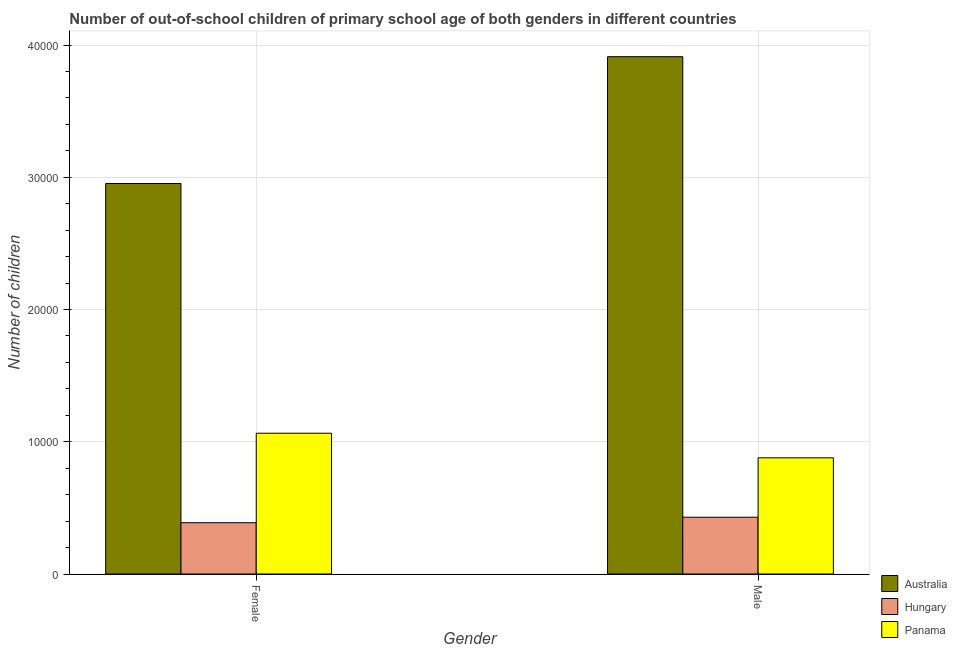How many different coloured bars are there?
Ensure brevity in your answer.  3. Are the number of bars on each tick of the X-axis equal?
Ensure brevity in your answer.  Yes. How many bars are there on the 1st tick from the right?
Make the answer very short. 3. What is the number of female out-of-school students in Australia?
Ensure brevity in your answer.  2.95e+04. Across all countries, what is the maximum number of male out-of-school students?
Offer a very short reply. 3.91e+04. Across all countries, what is the minimum number of male out-of-school students?
Your answer should be compact. 4293. In which country was the number of female out-of-school students maximum?
Ensure brevity in your answer.  Australia. In which country was the number of female out-of-school students minimum?
Provide a short and direct response. Hungary. What is the total number of male out-of-school students in the graph?
Your answer should be very brief. 5.22e+04. What is the difference between the number of male out-of-school students in Panama and that in Australia?
Your answer should be compact. -3.03e+04. What is the difference between the number of female out-of-school students in Hungary and the number of male out-of-school students in Australia?
Your response must be concise. -3.52e+04. What is the average number of male out-of-school students per country?
Make the answer very short. 1.74e+04. What is the difference between the number of female out-of-school students and number of male out-of-school students in Australia?
Provide a succinct answer. -9589. In how many countries, is the number of female out-of-school students greater than 10000 ?
Make the answer very short. 2. What is the ratio of the number of female out-of-school students in Australia to that in Hungary?
Keep it short and to the point. 7.61. In how many countries, is the number of female out-of-school students greater than the average number of female out-of-school students taken over all countries?
Your response must be concise. 1. What does the 3rd bar from the right in Male represents?
Your response must be concise. Australia. Are all the bars in the graph horizontal?
Your answer should be very brief. No. What is the difference between two consecutive major ticks on the Y-axis?
Your answer should be compact. 10000. Are the values on the major ticks of Y-axis written in scientific E-notation?
Your answer should be compact. No. How many legend labels are there?
Ensure brevity in your answer.  3. How are the legend labels stacked?
Make the answer very short. Vertical. What is the title of the graph?
Offer a terse response. Number of out-of-school children of primary school age of both genders in different countries. Does "Rwanda" appear as one of the legend labels in the graph?
Provide a succinct answer. No. What is the label or title of the Y-axis?
Your answer should be very brief. Number of children. What is the Number of children of Australia in Female?
Ensure brevity in your answer.  2.95e+04. What is the Number of children of Hungary in Female?
Offer a terse response. 3879. What is the Number of children of Panama in Female?
Make the answer very short. 1.06e+04. What is the Number of children of Australia in Male?
Ensure brevity in your answer.  3.91e+04. What is the Number of children in Hungary in Male?
Provide a short and direct response. 4293. What is the Number of children in Panama in Male?
Your answer should be very brief. 8786. Across all Gender, what is the maximum Number of children of Australia?
Keep it short and to the point. 3.91e+04. Across all Gender, what is the maximum Number of children of Hungary?
Provide a succinct answer. 4293. Across all Gender, what is the maximum Number of children of Panama?
Offer a very short reply. 1.06e+04. Across all Gender, what is the minimum Number of children in Australia?
Make the answer very short. 2.95e+04. Across all Gender, what is the minimum Number of children in Hungary?
Provide a succinct answer. 3879. Across all Gender, what is the minimum Number of children in Panama?
Your answer should be very brief. 8786. What is the total Number of children in Australia in the graph?
Offer a very short reply. 6.86e+04. What is the total Number of children of Hungary in the graph?
Keep it short and to the point. 8172. What is the total Number of children in Panama in the graph?
Your response must be concise. 1.94e+04. What is the difference between the Number of children in Australia in Female and that in Male?
Provide a short and direct response. -9589. What is the difference between the Number of children of Hungary in Female and that in Male?
Provide a succinct answer. -414. What is the difference between the Number of children in Panama in Female and that in Male?
Provide a short and direct response. 1859. What is the difference between the Number of children of Australia in Female and the Number of children of Hungary in Male?
Your response must be concise. 2.52e+04. What is the difference between the Number of children in Australia in Female and the Number of children in Panama in Male?
Offer a terse response. 2.07e+04. What is the difference between the Number of children in Hungary in Female and the Number of children in Panama in Male?
Keep it short and to the point. -4907. What is the average Number of children in Australia per Gender?
Provide a succinct answer. 3.43e+04. What is the average Number of children of Hungary per Gender?
Your response must be concise. 4086. What is the average Number of children of Panama per Gender?
Your answer should be compact. 9715.5. What is the difference between the Number of children of Australia and Number of children of Hungary in Female?
Keep it short and to the point. 2.56e+04. What is the difference between the Number of children in Australia and Number of children in Panama in Female?
Provide a succinct answer. 1.89e+04. What is the difference between the Number of children of Hungary and Number of children of Panama in Female?
Make the answer very short. -6766. What is the difference between the Number of children in Australia and Number of children in Hungary in Male?
Keep it short and to the point. 3.48e+04. What is the difference between the Number of children in Australia and Number of children in Panama in Male?
Make the answer very short. 3.03e+04. What is the difference between the Number of children in Hungary and Number of children in Panama in Male?
Provide a succinct answer. -4493. What is the ratio of the Number of children of Australia in Female to that in Male?
Your answer should be compact. 0.75. What is the ratio of the Number of children of Hungary in Female to that in Male?
Ensure brevity in your answer.  0.9. What is the ratio of the Number of children in Panama in Female to that in Male?
Provide a short and direct response. 1.21. What is the difference between the highest and the second highest Number of children in Australia?
Offer a very short reply. 9589. What is the difference between the highest and the second highest Number of children of Hungary?
Keep it short and to the point. 414. What is the difference between the highest and the second highest Number of children of Panama?
Provide a short and direct response. 1859. What is the difference between the highest and the lowest Number of children in Australia?
Your answer should be very brief. 9589. What is the difference between the highest and the lowest Number of children in Hungary?
Offer a very short reply. 414. What is the difference between the highest and the lowest Number of children in Panama?
Keep it short and to the point. 1859. 